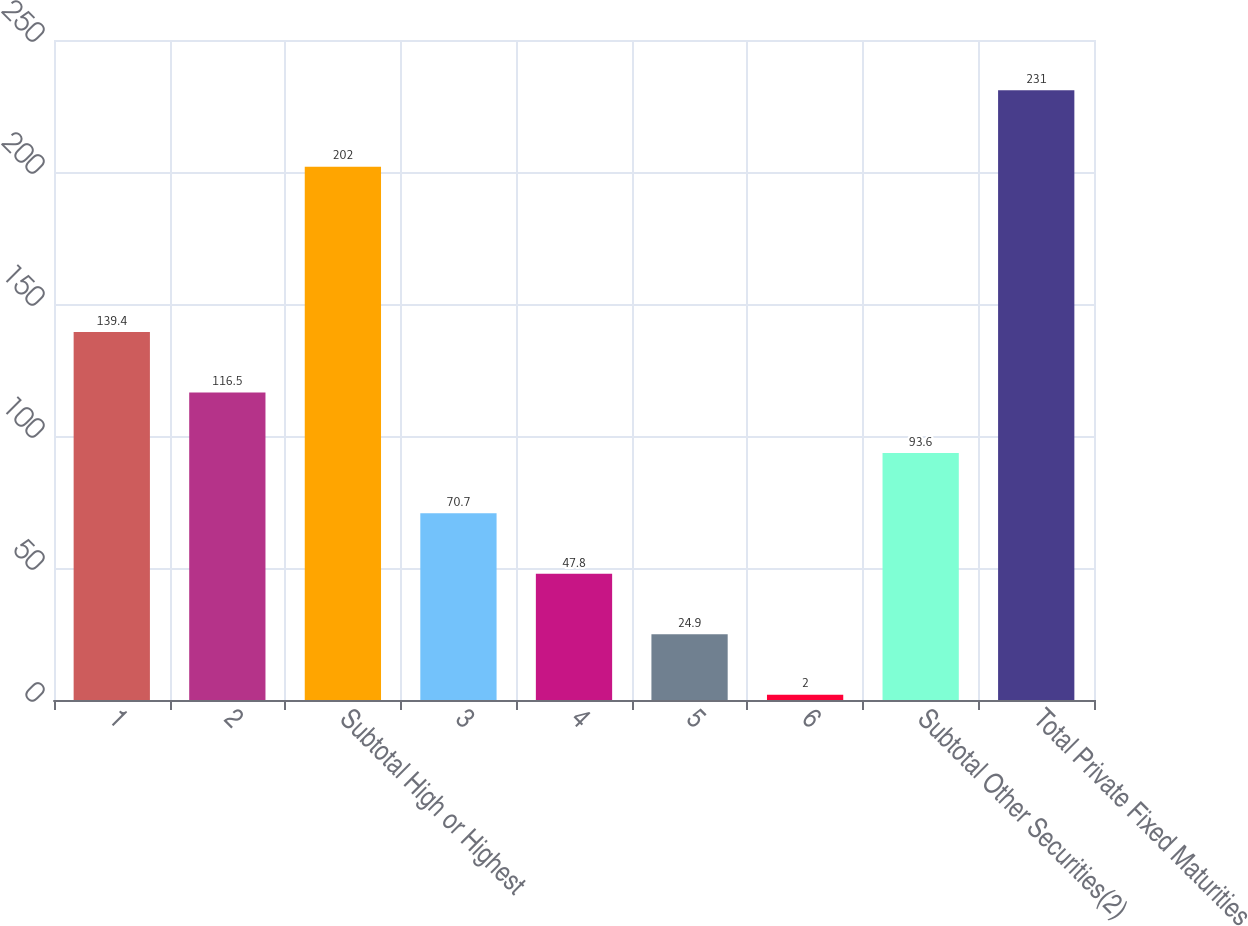Convert chart to OTSL. <chart><loc_0><loc_0><loc_500><loc_500><bar_chart><fcel>1<fcel>2<fcel>Subtotal High or Highest<fcel>3<fcel>4<fcel>5<fcel>6<fcel>Subtotal Other Securities(2)<fcel>Total Private Fixed Maturities<nl><fcel>139.4<fcel>116.5<fcel>202<fcel>70.7<fcel>47.8<fcel>24.9<fcel>2<fcel>93.6<fcel>231<nl></chart> 